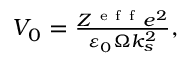Convert formula to latex. <formula><loc_0><loc_0><loc_500><loc_500>\begin{array} { r } { V _ { 0 } = \frac { Z ^ { e f f } e ^ { 2 } } { \varepsilon _ { 0 } \Omega k _ { s } ^ { 2 } } , } \end{array}</formula> 